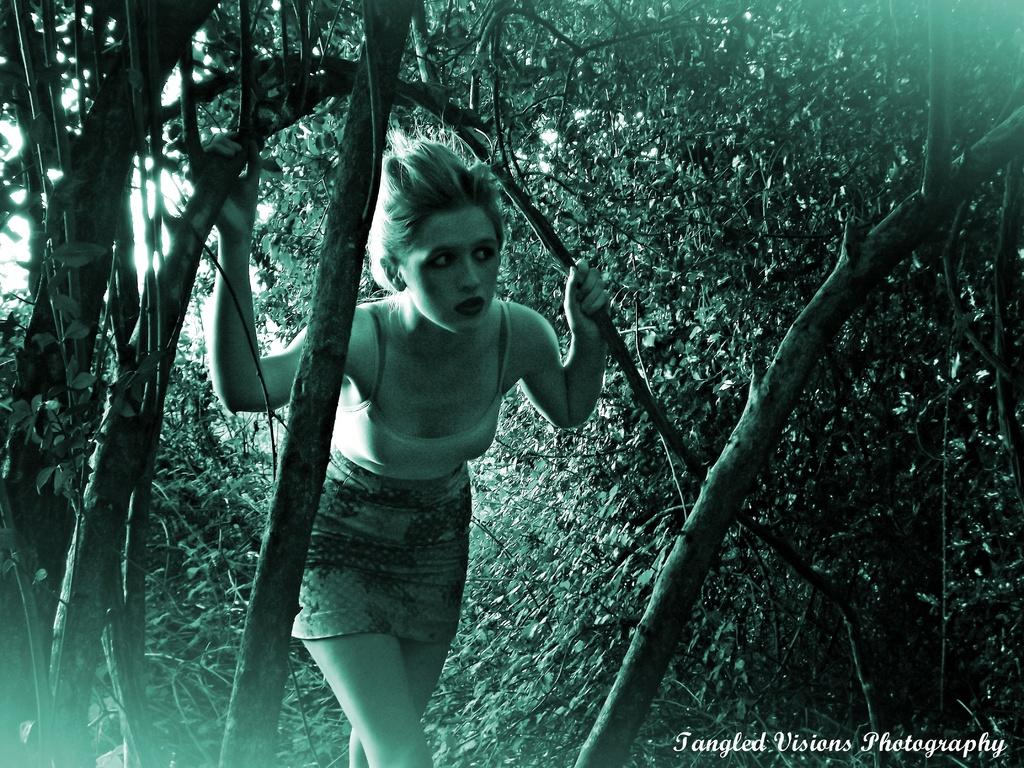What is the woman in the image doing? The woman is standing in the image and holding a branch. What can be seen in the background of the image? There are trees in the image. Is there any text or marking visible in the image? Yes, there is a watermark at the bottom right side of the image. What type of chalk is the woman using to draw a border around the trees in the image? There is no chalk or drawing activity present in the image. Who is the woman's partner in the image? There is no indication of a partner or relationship in the image. 